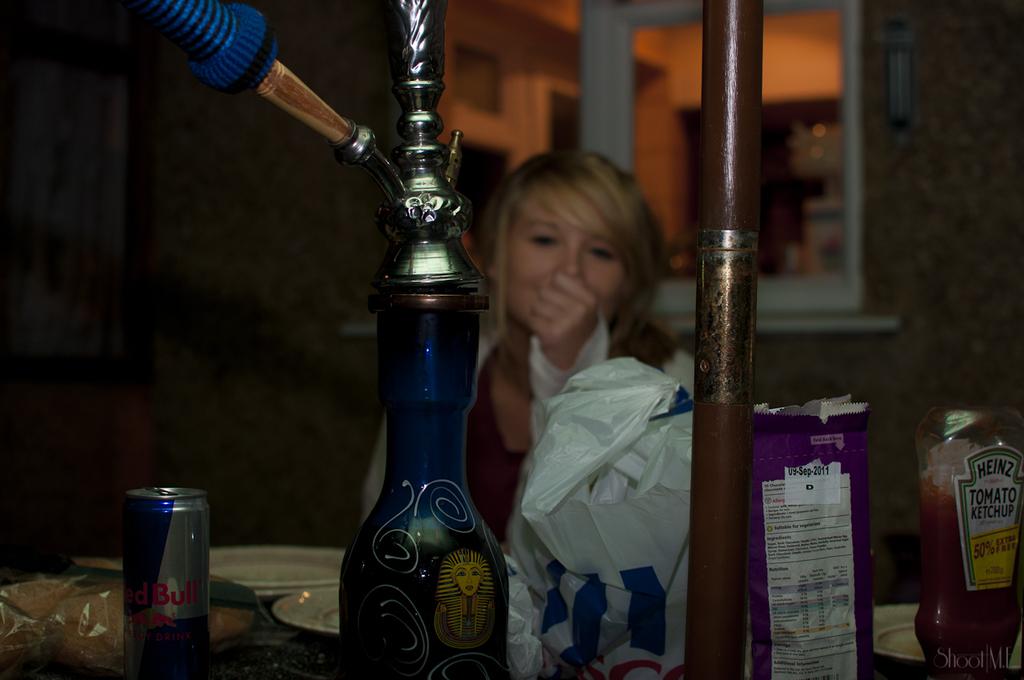What brand of energy drink is shown?
Your answer should be very brief. Red bull. 